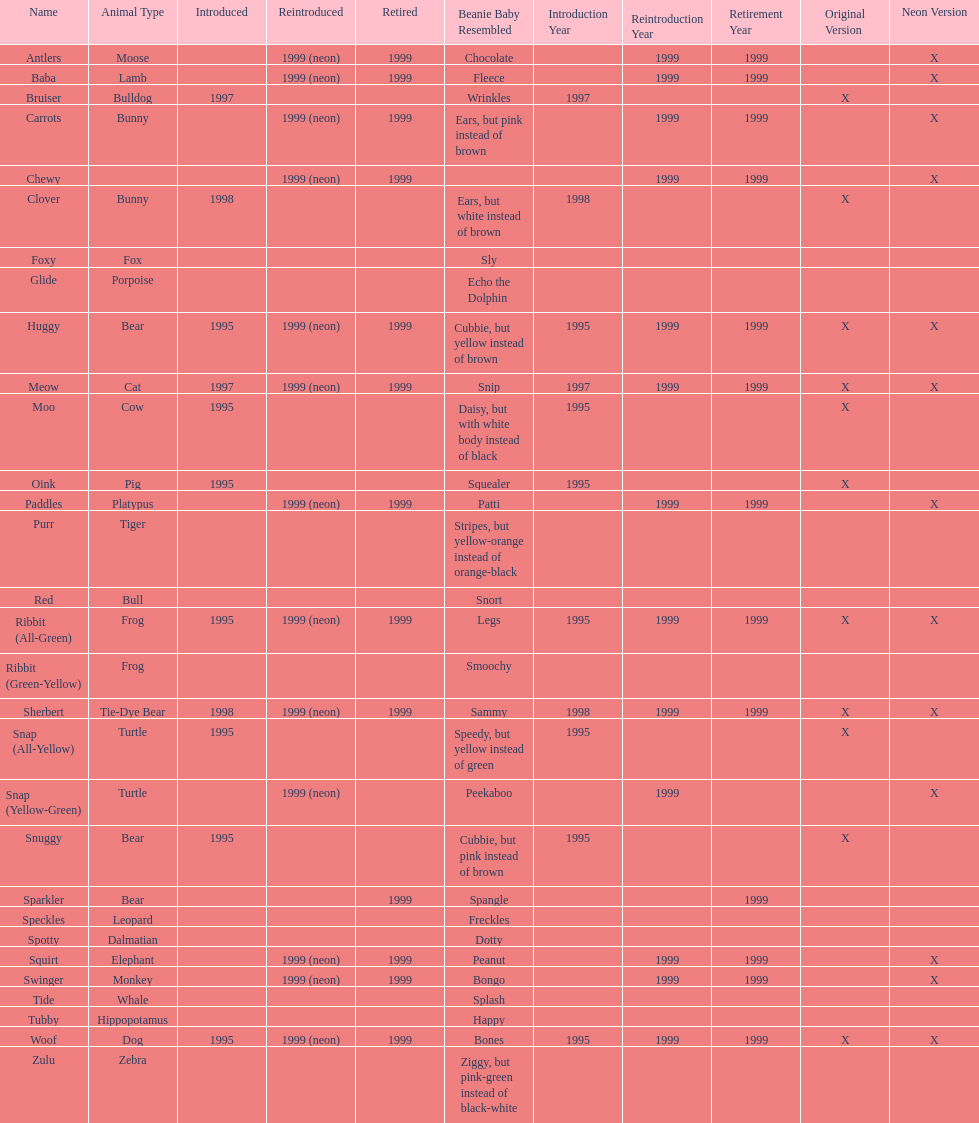Parse the table in full. {'header': ['Name', 'Animal Type', 'Introduced', 'Reintroduced', 'Retired', 'Beanie Baby Resembled', 'Introduction Year', 'Reintroduction Year', 'Retirement Year', 'Original Version', 'Neon Version'], 'rows': [['Antlers', 'Moose', '', '1999 (neon)', '1999', 'Chocolate', '', '1999', '1999', '', 'X'], ['Baba', 'Lamb', '', '1999 (neon)', '1999', 'Fleece', '', '1999', '1999', '', 'X'], ['Bruiser', 'Bulldog', '1997', '', '', 'Wrinkles', '1997', '', '', 'X', ''], ['Carrots', 'Bunny', '', '1999 (neon)', '1999', 'Ears, but pink instead of brown', '', '1999', '1999', '', 'X'], ['Chewy', '', '', '1999 (neon)', '1999', '', '', '1999', '1999', '', 'X'], ['Clover', 'Bunny', '1998', '', '', 'Ears, but white instead of brown', '1998', '', '', 'X', ''], ['Foxy', 'Fox', '', '', '', 'Sly', '', '', '', '', ''], ['Glide', 'Porpoise', '', '', '', 'Echo the Dolphin', '', '', '', '', ''], ['Huggy', 'Bear', '1995', '1999 (neon)', '1999', 'Cubbie, but yellow instead of brown', '1995', '1999', '1999', 'X', 'X'], ['Meow', 'Cat', '1997', '1999 (neon)', '1999', 'Snip', '1997', '1999', '1999', 'X', 'X'], ['Moo', 'Cow', '1995', '', '', 'Daisy, but with white body instead of black', '1995', '', '', 'X', ''], ['Oink', 'Pig', '1995', '', '', 'Squealer', '1995', '', '', 'X', ''], ['Paddles', 'Platypus', '', '1999 (neon)', '1999', 'Patti', '', '1999', '1999', '', 'X'], ['Purr', 'Tiger', '', '', '', 'Stripes, but yellow-orange instead of orange-black', '', '', '', '', ''], ['Red', 'Bull', '', '', '', 'Snort', '', '', '', '', ''], ['Ribbit (All-Green)', 'Frog', '1995', '1999 (neon)', '1999', 'Legs', '1995', '1999', '1999', 'X', 'X'], ['Ribbit (Green-Yellow)', 'Frog', '', '', '', 'Smoochy', '', '', '', '', ''], ['Sherbert', 'Tie-Dye Bear', '1998', '1999 (neon)', '1999', 'Sammy', '1998', '1999', '1999', 'X', 'X'], ['Snap (All-Yellow)', 'Turtle', '1995', '', '', 'Speedy, but yellow instead of green', '1995', '', '', 'X', ''], ['Snap (Yellow-Green)', 'Turtle', '', '1999 (neon)', '', 'Peekaboo', '', '1999', '', '', 'X'], ['Snuggy', 'Bear', '1995', '', '', 'Cubbie, but pink instead of brown', '1995', '', '', 'X', ''], ['Sparkler', 'Bear', '', '', '1999', 'Spangle', '', '', '1999', '', ''], ['Speckles', 'Leopard', '', '', '', 'Freckles', '', '', '', '', ''], ['Spotty', 'Dalmatian', '', '', '', 'Dotty', '', '', '', '', ''], ['Squirt', 'Elephant', '', '1999 (neon)', '1999', 'Peanut', '', '1999', '1999', '', 'X'], ['Swinger', 'Monkey', '', '1999 (neon)', '1999', 'Bongo', '', '1999', '1999', '', 'X'], ['Tide', 'Whale', '', '', '', 'Splash', '', '', '', '', ''], ['Tubby', 'Hippopotamus', '', '', '', 'Happy', '', '', '', '', ''], ['Woof', 'Dog', '1995', '1999 (neon)', '1999', 'Bones', '1995', '1999', '1999', 'X', 'X'], ['Zulu', 'Zebra', '', '', '', 'Ziggy, but pink-green instead of black-white', '', '', '', '', '']]} What is the total number of pillow pals that were reintroduced as a neon variety? 13. 